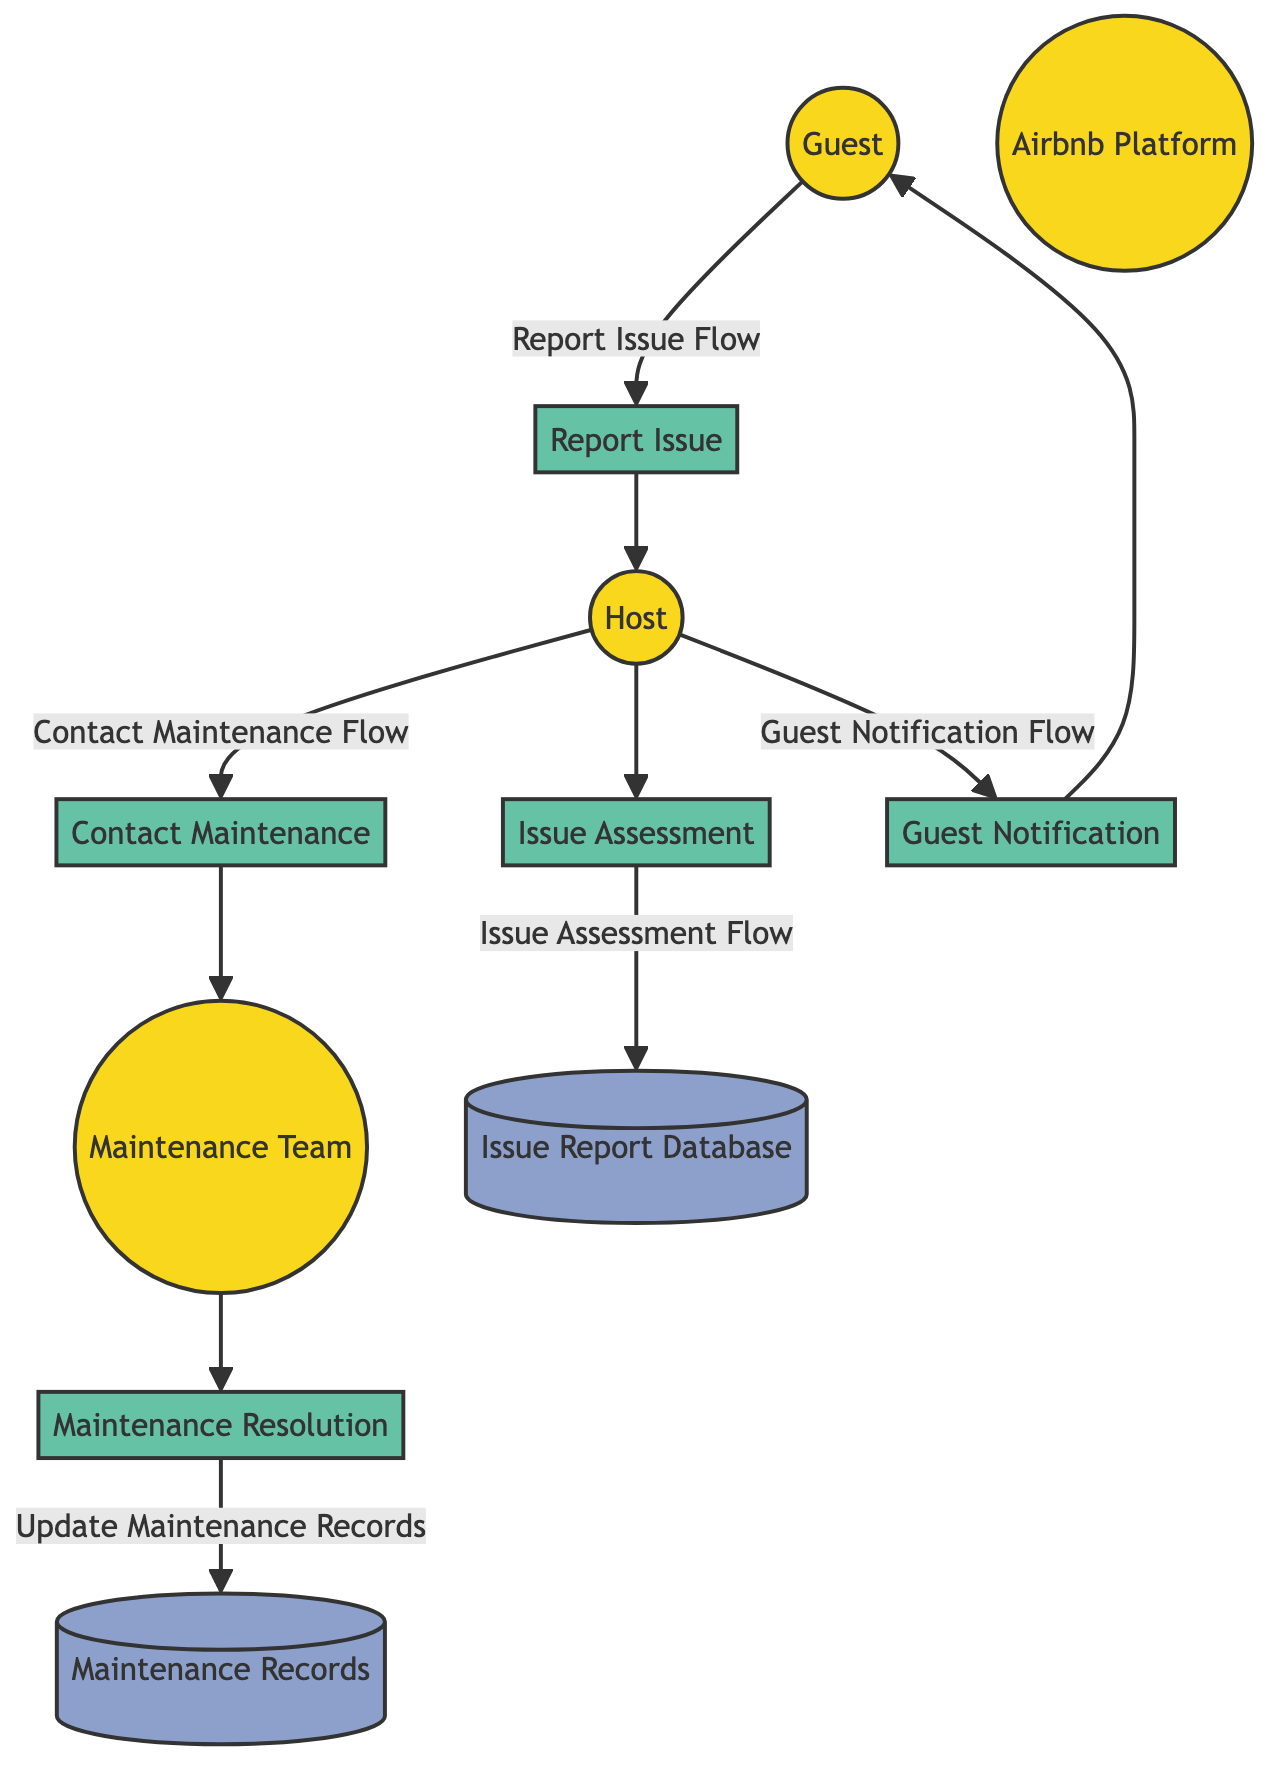What entity is responsible for reporting maintenance issues? The entity responsible for reporting maintenance issues is the Guest, as indicated by the flow from Guest to the Report Issue process.
Answer: Guest How many processes are defined in the diagram? The diagram outlines a total of five processes related to maintenance requests: Report Issue, Issue Assessment, Contact Maintenance, Maintenance Resolution, and Guest Notification.
Answer: Five What is the flow from the host to the issue report database? The flow from the host to the Issue Report Database is labeled as the Issue Assessment Flow, where the host records details of the assessed issue.
Answer: Issue Assessment Flow Which entity receives updates about the resolution of maintenance issues? The entity that receives updates about the resolution of maintenance issues is the Guest, as shown by the flow from the Guest Notification process back to the Guest.
Answer: Guest What data store records maintenance activities and resolutions? The data store that records maintenance activities and resolutions is the Maintenance Records, as indicated in the diagram.
Answer: Maintenance Records What process follows the Contact Maintenance process? The process that follows the Contact Maintenance process is Maintenance Resolution, where the maintenance team addresses the reported issue.
Answer: Maintenance Resolution How does the maintenance team provide resolution details? The maintenance team provides resolution details by updating the Maintenance Records dataset after resolving the issue, as indicated by the Update Maintenance Records flow.
Answer: Update Maintenance Records From which entity does the Report Issue flow originate? The Report Issue flow originates from the Guest entity, where the guest initiates the maintenance request through the Airbnb platform.
Answer: Guest What is the final process that communicates with the guest? The final process that communicates with the guest is Guest Notification, as this process is designated to update the guest about the resolution status of their reported issue.
Answer: Guest Notification 